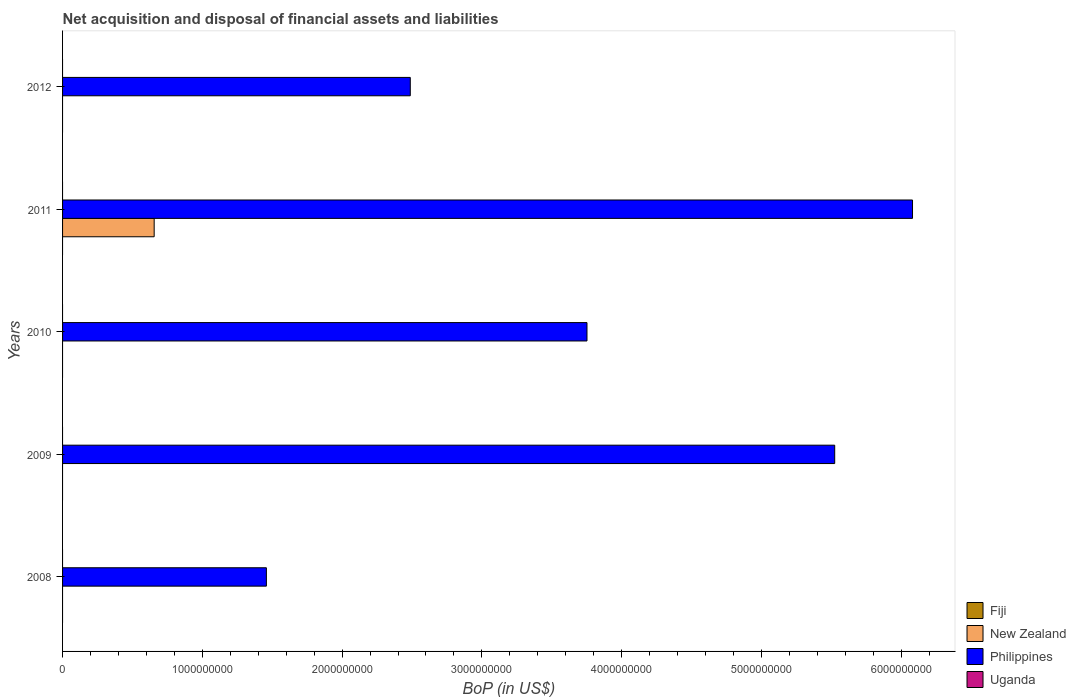How many different coloured bars are there?
Your answer should be very brief. 2. Are the number of bars per tick equal to the number of legend labels?
Your response must be concise. No. How many bars are there on the 3rd tick from the top?
Offer a very short reply. 1. How many bars are there on the 2nd tick from the bottom?
Provide a short and direct response. 1. What is the label of the 5th group of bars from the top?
Your answer should be very brief. 2008. Across all years, what is the maximum Balance of Payments in New Zealand?
Offer a very short reply. 6.55e+08. What is the total Balance of Payments in Philippines in the graph?
Provide a succinct answer. 1.93e+1. What is the difference between the Balance of Payments in Philippines in 2010 and that in 2012?
Give a very brief answer. 1.26e+09. What is the difference between the Balance of Payments in Philippines in 2010 and the Balance of Payments in New Zealand in 2011?
Your answer should be compact. 3.10e+09. What is the average Balance of Payments in New Zealand per year?
Ensure brevity in your answer.  1.31e+08. Is the Balance of Payments in Philippines in 2011 less than that in 2012?
Your answer should be very brief. No. What is the difference between the highest and the second highest Balance of Payments in Philippines?
Your answer should be very brief. 5.57e+08. What is the difference between the highest and the lowest Balance of Payments in Philippines?
Provide a short and direct response. 4.62e+09. In how many years, is the Balance of Payments in New Zealand greater than the average Balance of Payments in New Zealand taken over all years?
Your response must be concise. 1. Is the sum of the Balance of Payments in Philippines in 2009 and 2012 greater than the maximum Balance of Payments in New Zealand across all years?
Give a very brief answer. Yes. Is it the case that in every year, the sum of the Balance of Payments in Philippines and Balance of Payments in Fiji is greater than the Balance of Payments in New Zealand?
Provide a short and direct response. Yes. Are all the bars in the graph horizontal?
Your answer should be compact. Yes. What is the difference between two consecutive major ticks on the X-axis?
Your answer should be very brief. 1.00e+09. Are the values on the major ticks of X-axis written in scientific E-notation?
Provide a succinct answer. No. Does the graph contain any zero values?
Offer a very short reply. Yes. Does the graph contain grids?
Give a very brief answer. No. Where does the legend appear in the graph?
Your answer should be compact. Bottom right. How are the legend labels stacked?
Offer a terse response. Vertical. What is the title of the graph?
Ensure brevity in your answer.  Net acquisition and disposal of financial assets and liabilities. What is the label or title of the X-axis?
Your answer should be compact. BoP (in US$). What is the BoP (in US$) in Fiji in 2008?
Offer a very short reply. 0. What is the BoP (in US$) in New Zealand in 2008?
Provide a succinct answer. 0. What is the BoP (in US$) of Philippines in 2008?
Keep it short and to the point. 1.46e+09. What is the BoP (in US$) of Fiji in 2009?
Offer a very short reply. 0. What is the BoP (in US$) of New Zealand in 2009?
Provide a short and direct response. 0. What is the BoP (in US$) of Philippines in 2009?
Offer a very short reply. 5.52e+09. What is the BoP (in US$) in New Zealand in 2010?
Your answer should be very brief. 0. What is the BoP (in US$) of Philippines in 2010?
Offer a terse response. 3.75e+09. What is the BoP (in US$) in New Zealand in 2011?
Keep it short and to the point. 6.55e+08. What is the BoP (in US$) of Philippines in 2011?
Ensure brevity in your answer.  6.08e+09. What is the BoP (in US$) of Philippines in 2012?
Your answer should be compact. 2.49e+09. Across all years, what is the maximum BoP (in US$) of New Zealand?
Offer a very short reply. 6.55e+08. Across all years, what is the maximum BoP (in US$) in Philippines?
Provide a short and direct response. 6.08e+09. Across all years, what is the minimum BoP (in US$) of New Zealand?
Offer a very short reply. 0. Across all years, what is the minimum BoP (in US$) in Philippines?
Give a very brief answer. 1.46e+09. What is the total BoP (in US$) in Fiji in the graph?
Provide a short and direct response. 0. What is the total BoP (in US$) in New Zealand in the graph?
Your response must be concise. 6.55e+08. What is the total BoP (in US$) in Philippines in the graph?
Make the answer very short. 1.93e+1. What is the total BoP (in US$) of Uganda in the graph?
Give a very brief answer. 0. What is the difference between the BoP (in US$) in Philippines in 2008 and that in 2009?
Your answer should be very brief. -4.07e+09. What is the difference between the BoP (in US$) of Philippines in 2008 and that in 2010?
Make the answer very short. -2.29e+09. What is the difference between the BoP (in US$) of Philippines in 2008 and that in 2011?
Make the answer very short. -4.62e+09. What is the difference between the BoP (in US$) of Philippines in 2008 and that in 2012?
Your answer should be compact. -1.03e+09. What is the difference between the BoP (in US$) of Philippines in 2009 and that in 2010?
Offer a terse response. 1.77e+09. What is the difference between the BoP (in US$) of Philippines in 2009 and that in 2011?
Offer a terse response. -5.57e+08. What is the difference between the BoP (in US$) of Philippines in 2009 and that in 2012?
Make the answer very short. 3.04e+09. What is the difference between the BoP (in US$) of Philippines in 2010 and that in 2011?
Make the answer very short. -2.33e+09. What is the difference between the BoP (in US$) of Philippines in 2010 and that in 2012?
Keep it short and to the point. 1.26e+09. What is the difference between the BoP (in US$) in Philippines in 2011 and that in 2012?
Provide a succinct answer. 3.59e+09. What is the difference between the BoP (in US$) in New Zealand in 2011 and the BoP (in US$) in Philippines in 2012?
Give a very brief answer. -1.83e+09. What is the average BoP (in US$) in New Zealand per year?
Ensure brevity in your answer.  1.31e+08. What is the average BoP (in US$) in Philippines per year?
Provide a short and direct response. 3.86e+09. In the year 2011, what is the difference between the BoP (in US$) in New Zealand and BoP (in US$) in Philippines?
Offer a terse response. -5.43e+09. What is the ratio of the BoP (in US$) in Philippines in 2008 to that in 2009?
Provide a short and direct response. 0.26. What is the ratio of the BoP (in US$) of Philippines in 2008 to that in 2010?
Your response must be concise. 0.39. What is the ratio of the BoP (in US$) in Philippines in 2008 to that in 2011?
Make the answer very short. 0.24. What is the ratio of the BoP (in US$) of Philippines in 2008 to that in 2012?
Ensure brevity in your answer.  0.59. What is the ratio of the BoP (in US$) in Philippines in 2009 to that in 2010?
Offer a terse response. 1.47. What is the ratio of the BoP (in US$) of Philippines in 2009 to that in 2011?
Your answer should be compact. 0.91. What is the ratio of the BoP (in US$) in Philippines in 2009 to that in 2012?
Offer a very short reply. 2.22. What is the ratio of the BoP (in US$) in Philippines in 2010 to that in 2011?
Your response must be concise. 0.62. What is the ratio of the BoP (in US$) of Philippines in 2010 to that in 2012?
Provide a succinct answer. 1.51. What is the ratio of the BoP (in US$) of Philippines in 2011 to that in 2012?
Keep it short and to the point. 2.44. What is the difference between the highest and the second highest BoP (in US$) in Philippines?
Ensure brevity in your answer.  5.57e+08. What is the difference between the highest and the lowest BoP (in US$) of New Zealand?
Your answer should be compact. 6.55e+08. What is the difference between the highest and the lowest BoP (in US$) in Philippines?
Offer a terse response. 4.62e+09. 